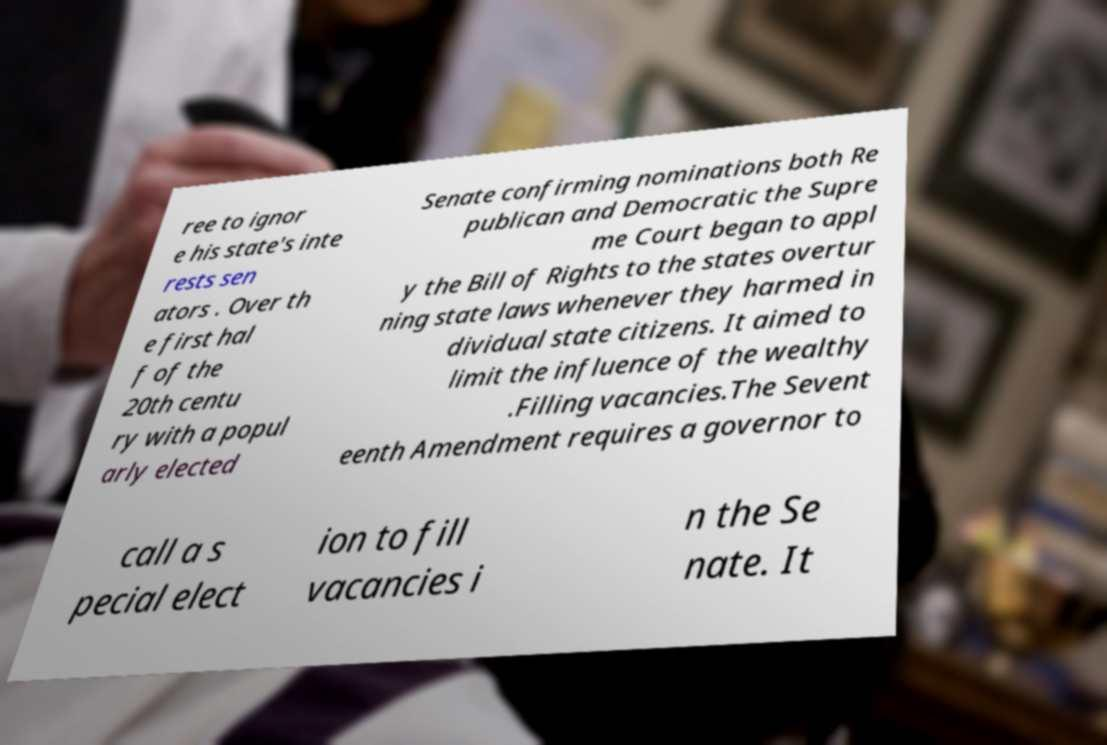I need the written content from this picture converted into text. Can you do that? ree to ignor e his state's inte rests sen ators . Over th e first hal f of the 20th centu ry with a popul arly elected Senate confirming nominations both Re publican and Democratic the Supre me Court began to appl y the Bill of Rights to the states overtur ning state laws whenever they harmed in dividual state citizens. It aimed to limit the influence of the wealthy .Filling vacancies.The Sevent eenth Amendment requires a governor to call a s pecial elect ion to fill vacancies i n the Se nate. It 